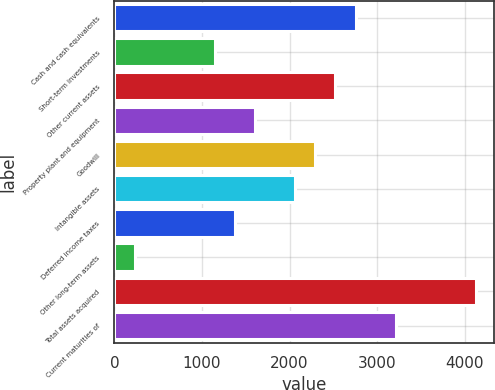Convert chart. <chart><loc_0><loc_0><loc_500><loc_500><bar_chart><fcel>Cash and cash equivalents<fcel>Short-term investments<fcel>Other current assets<fcel>Property plant and equipment<fcel>Goodwill<fcel>Intangible assets<fcel>Deferred income taxes<fcel>Other long-term assets<fcel>Total assets acquired<fcel>Current maturities of<nl><fcel>2753.2<fcel>1149.5<fcel>2524.1<fcel>1607.7<fcel>2295<fcel>2065.9<fcel>1378.6<fcel>233.1<fcel>4127.8<fcel>3211.4<nl></chart> 